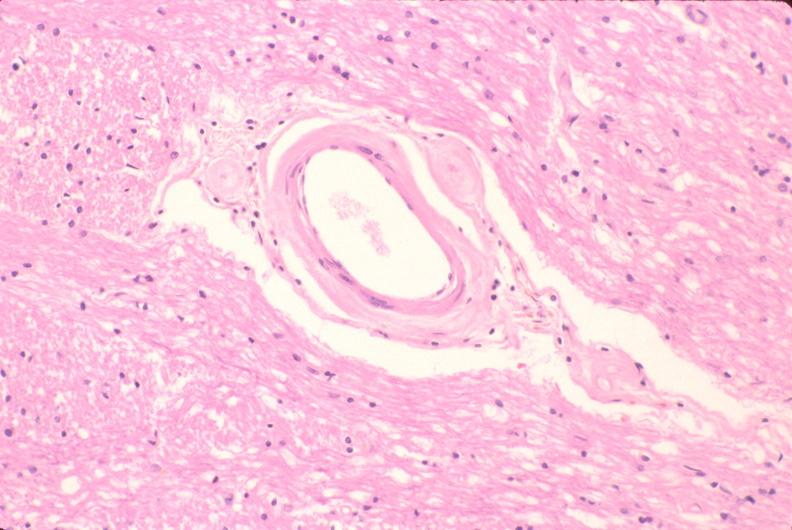s nervous present?
Answer the question using a single word or phrase. Yes 